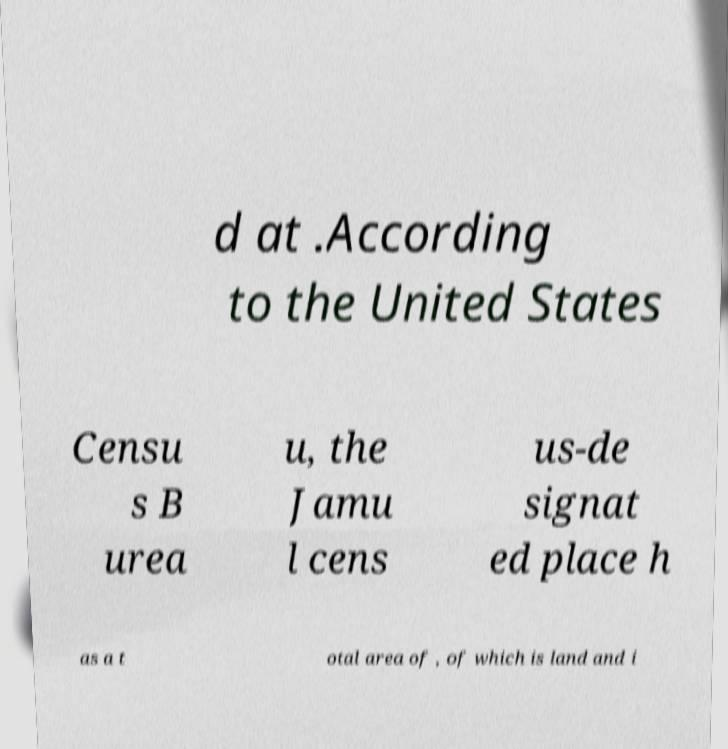Could you extract and type out the text from this image? d at .According to the United States Censu s B urea u, the Jamu l cens us-de signat ed place h as a t otal area of , of which is land and i 